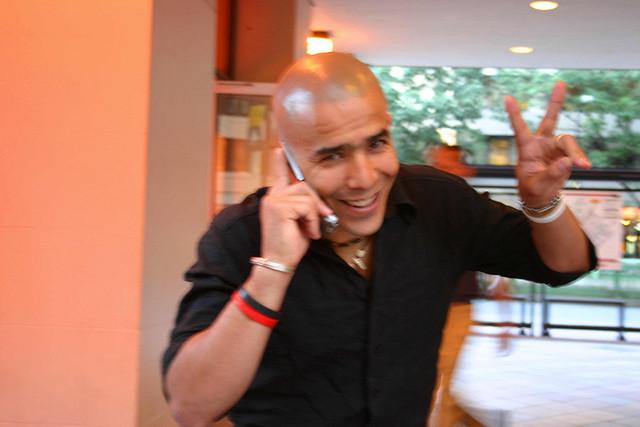Is this man bald?
Be succinct. Yes. Is the phone in danger of having wine spilled on it?
Write a very short answer. No. What color are the bracelets on the man's left arm?
Short answer required. Red and black. How many fingers are up?
Keep it brief. 2. 